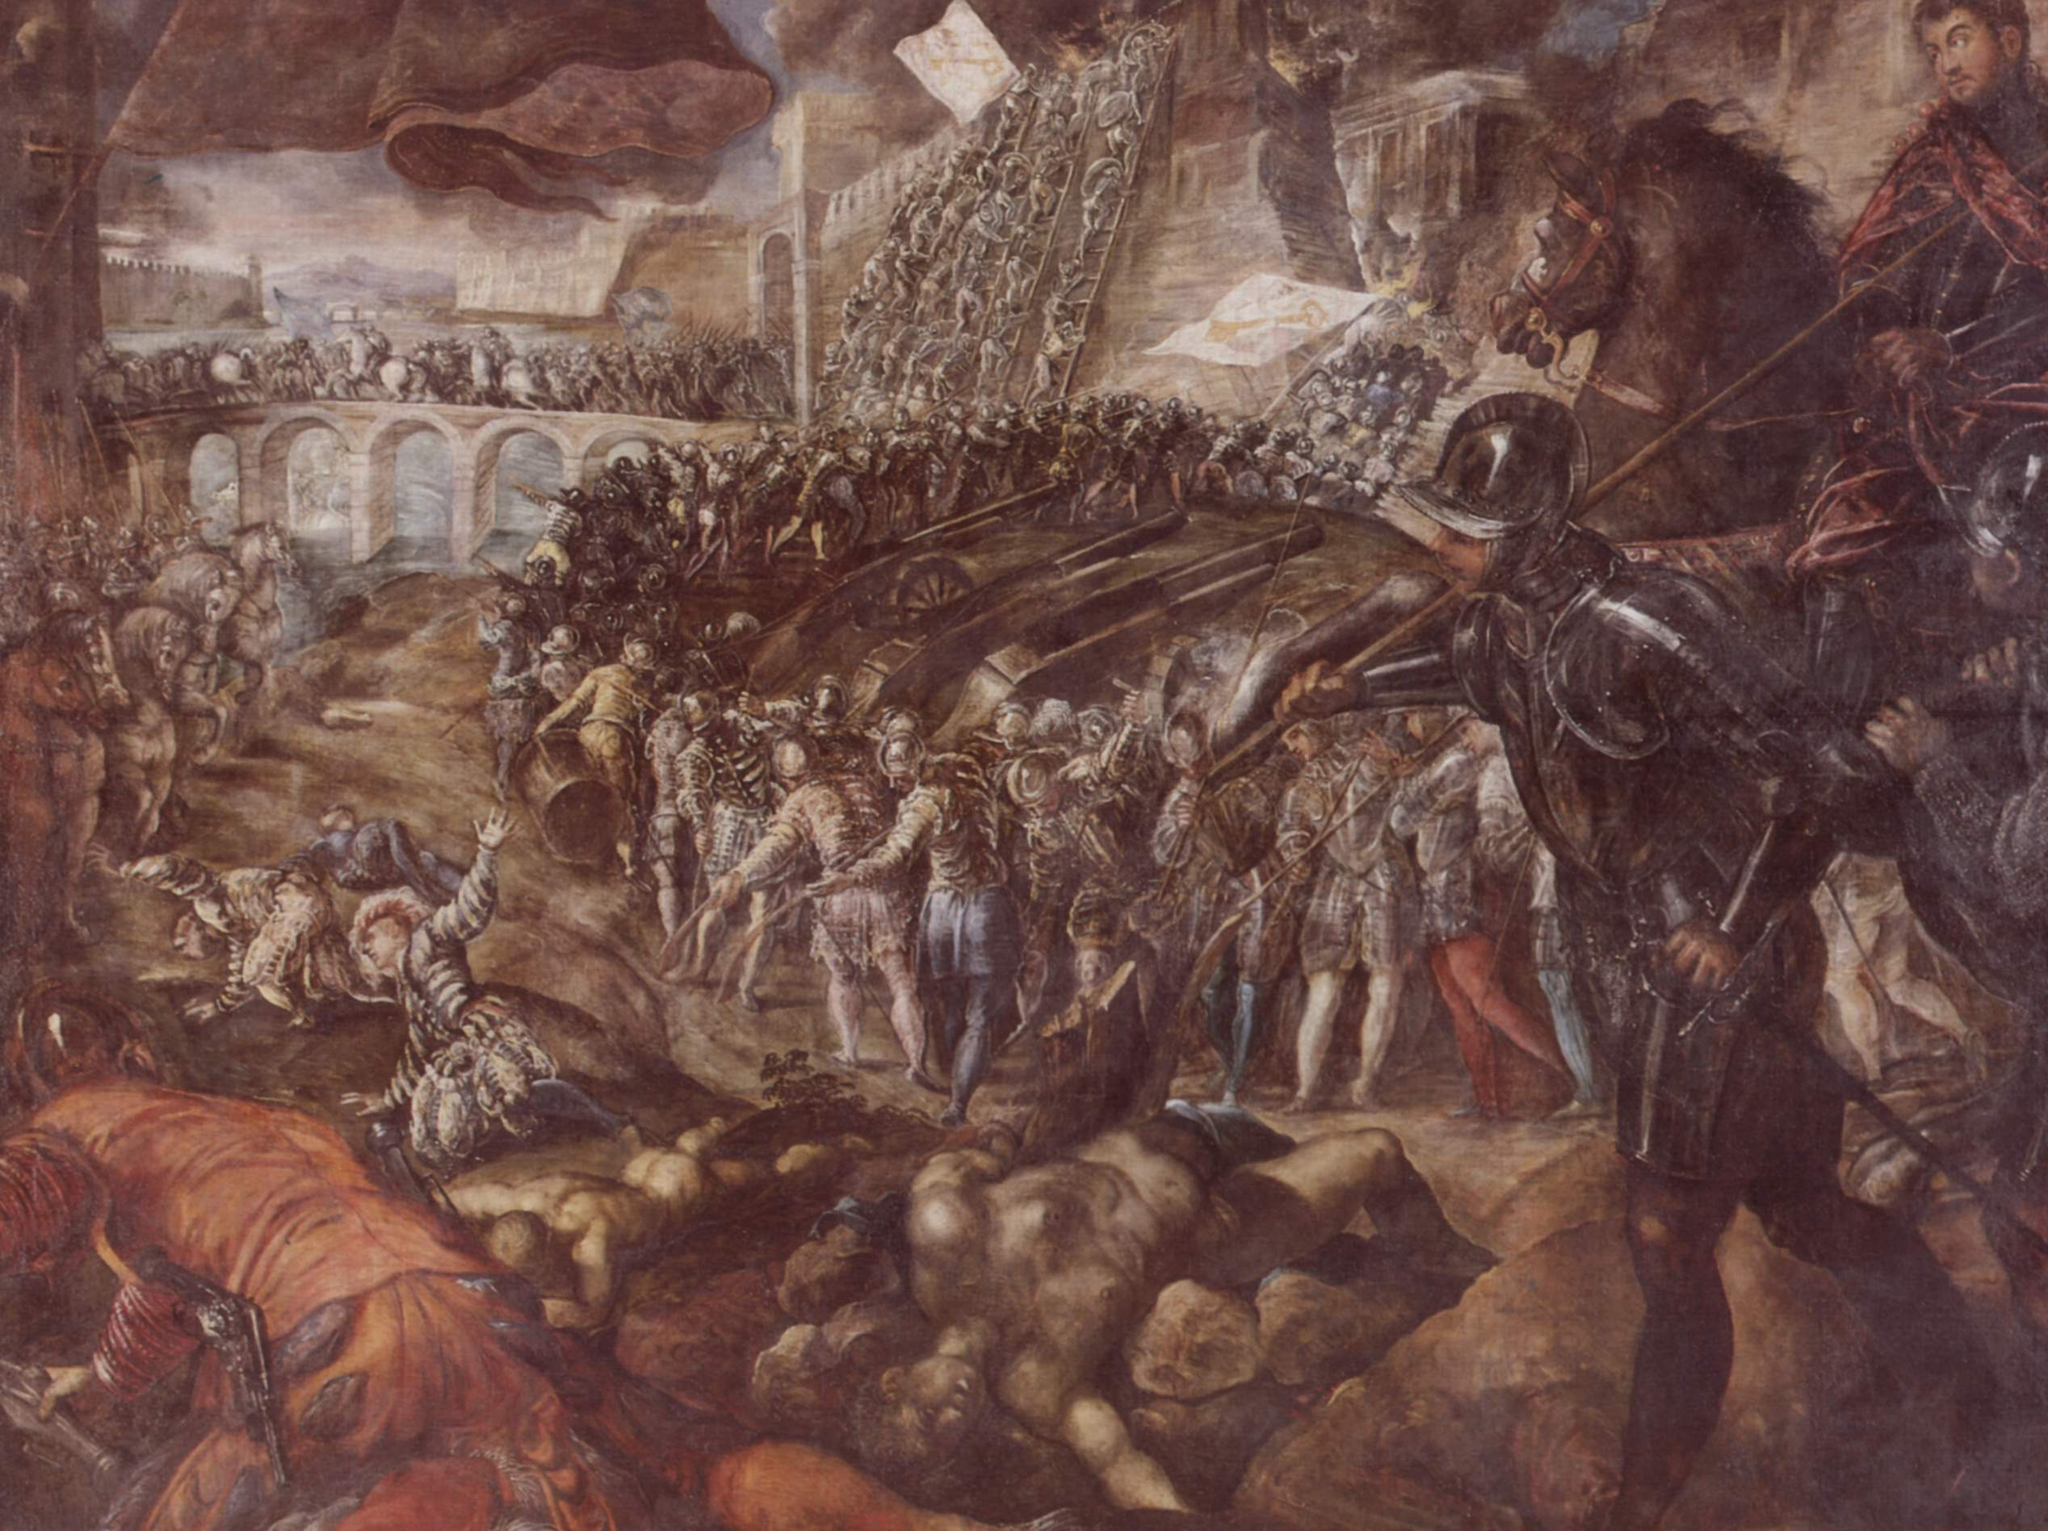If the animals in the scene could speak, what might they say? The startled horses, caught in the midst of the turmoil, might express a deep sense of distress and confusion. 'Why must men always turn to violence?' a noble steed might ponder, its eyes wide with fear. 'We were bred for service and loyalty, yet we are thrust into these horrors, sharing in the madness of human conflict.' Another horse, witnessing the death around it, might lament, 'Is this the legacy we are bound to witness, the cycle of war and bloodshed?' The animals, innocent participants in the brutality of human warfare, would reflect on the senselessness of the violence that engulfs them, yearning for a world where their strength and spirit are honored in peace rather than war. 